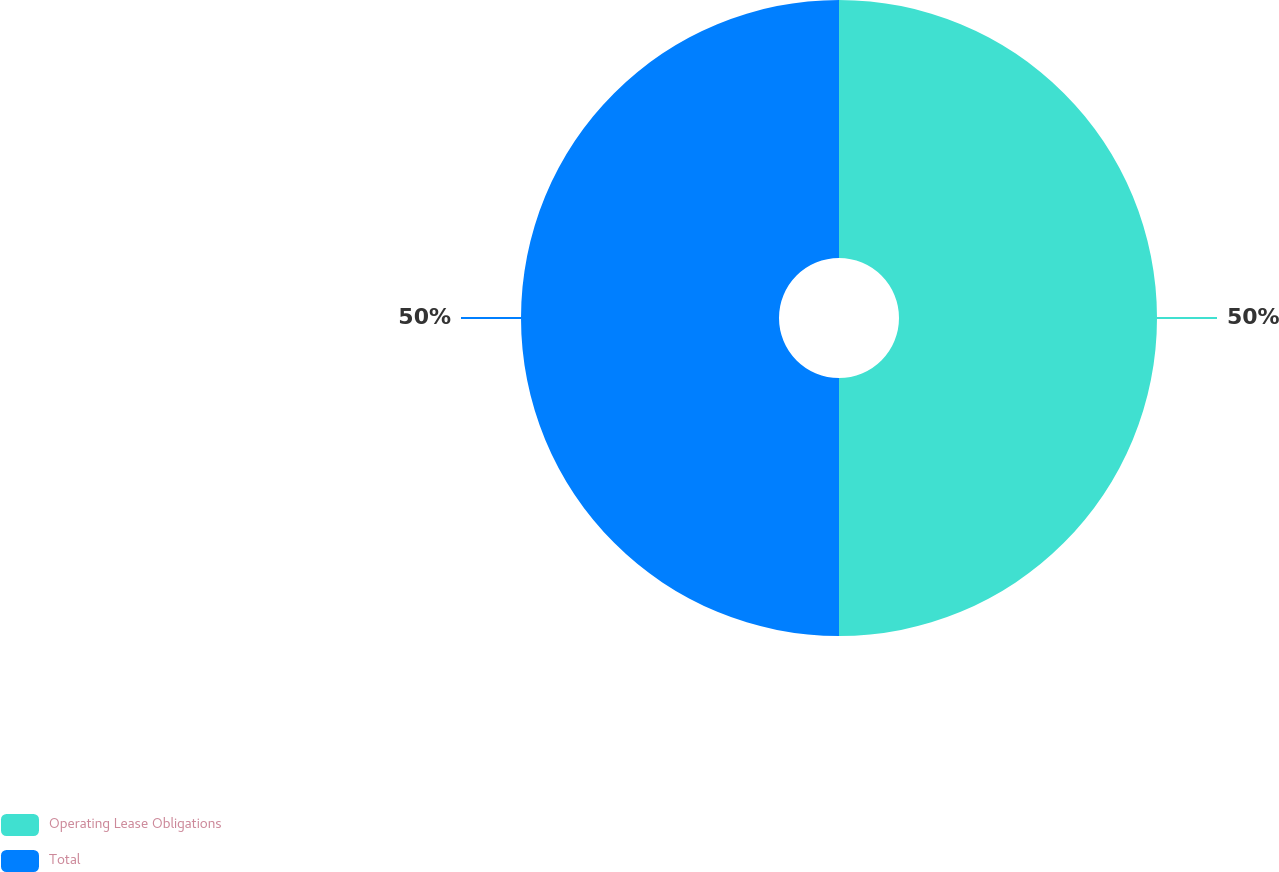<chart> <loc_0><loc_0><loc_500><loc_500><pie_chart><fcel>Operating Lease Obligations<fcel>Total<nl><fcel>50.0%<fcel>50.0%<nl></chart> 